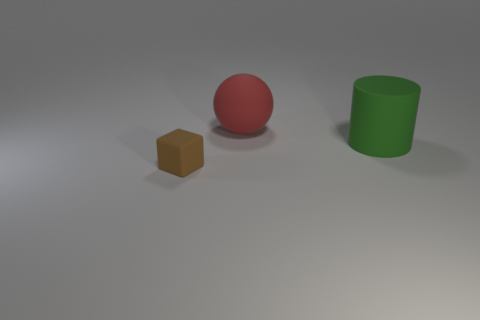Are any small gray shiny cubes visible?
Your answer should be compact. No. The thing that is behind the large green matte cylinder has what shape?
Make the answer very short. Sphere. How many objects are both to the right of the brown rubber block and in front of the big matte cylinder?
Make the answer very short. 0. Are there any green blocks that have the same material as the tiny brown block?
Ensure brevity in your answer.  No. What number of cylinders are either red things or small objects?
Provide a succinct answer. 0. What size is the green thing?
Ensure brevity in your answer.  Large. How many things are behind the small brown rubber block?
Provide a succinct answer. 2. What is the size of the matte object that is in front of the big thing to the right of the big matte ball?
Provide a succinct answer. Small. There is a rubber object to the left of the big rubber object that is to the left of the cylinder; what shape is it?
Offer a very short reply. Cube. What size is the matte object that is to the left of the matte cylinder and in front of the red ball?
Your response must be concise. Small. 